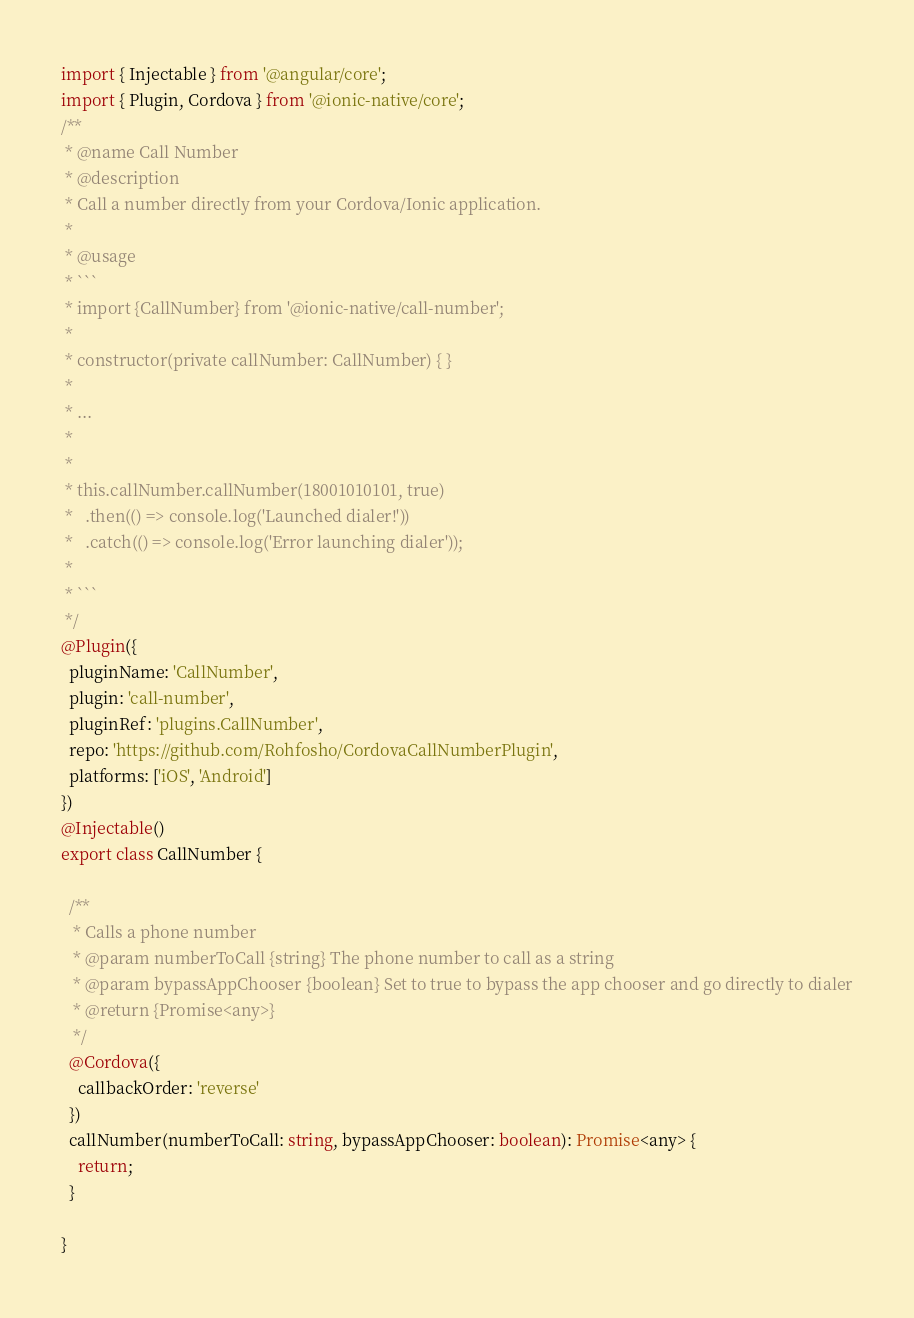Convert code to text. <code><loc_0><loc_0><loc_500><loc_500><_TypeScript_>import { Injectable } from '@angular/core';
import { Plugin, Cordova } from '@ionic-native/core';
/**
 * @name Call Number
 * @description
 * Call a number directly from your Cordova/Ionic application.
 *
 * @usage
 * ```
 * import {CallNumber} from '@ionic-native/call-number';
 *
 * constructor(private callNumber: CallNumber) { }
 *
 * ...
 *
 *
 * this.callNumber.callNumber(18001010101, true)
 *   .then(() => console.log('Launched dialer!'))
 *   .catch(() => console.log('Error launching dialer'));
 *
 * ```
 */
@Plugin({
  pluginName: 'CallNumber',
  plugin: 'call-number',
  pluginRef: 'plugins.CallNumber',
  repo: 'https://github.com/Rohfosho/CordovaCallNumberPlugin',
  platforms: ['iOS', 'Android']
})
@Injectable()
export class CallNumber {

  /**
   * Calls a phone number
   * @param numberToCall {string} The phone number to call as a string
   * @param bypassAppChooser {boolean} Set to true to bypass the app chooser and go directly to dialer
   * @return {Promise<any>}
   */
  @Cordova({
    callbackOrder: 'reverse'
  })
  callNumber(numberToCall: string, bypassAppChooser: boolean): Promise<any> {
    return;
  }

}
</code> 